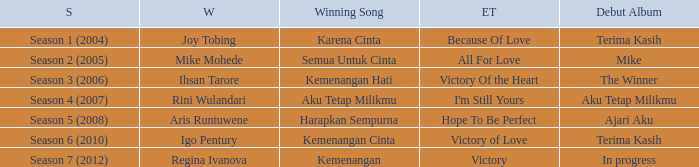Could you help me parse every detail presented in this table? {'header': ['S', 'W', 'Winning Song', 'ET', 'Debut Album'], 'rows': [['Season 1 (2004)', 'Joy Tobing', 'Karena Cinta', 'Because Of Love', 'Terima Kasih'], ['Season 2 (2005)', 'Mike Mohede', 'Semua Untuk Cinta', 'All For Love', 'Mike'], ['Season 3 (2006)', 'Ihsan Tarore', 'Kemenangan Hati', 'Victory Of the Heart', 'The Winner'], ['Season 4 (2007)', 'Rini Wulandari', 'Aku Tetap Milikmu', "I'm Still Yours", 'Aku Tetap Milikmu'], ['Season 5 (2008)', 'Aris Runtuwene', 'Harapkan Sempurna', 'Hope To Be Perfect', 'Ajari Aku'], ['Season 6 (2010)', 'Igo Pentury', 'Kemenangan Cinta', 'Victory of Love', 'Terima Kasih'], ['Season 7 (2012)', 'Regina Ivanova', 'Kemenangan', 'Victory', 'In progress']]} Which winning song had a debut album in progress? Kemenangan. 